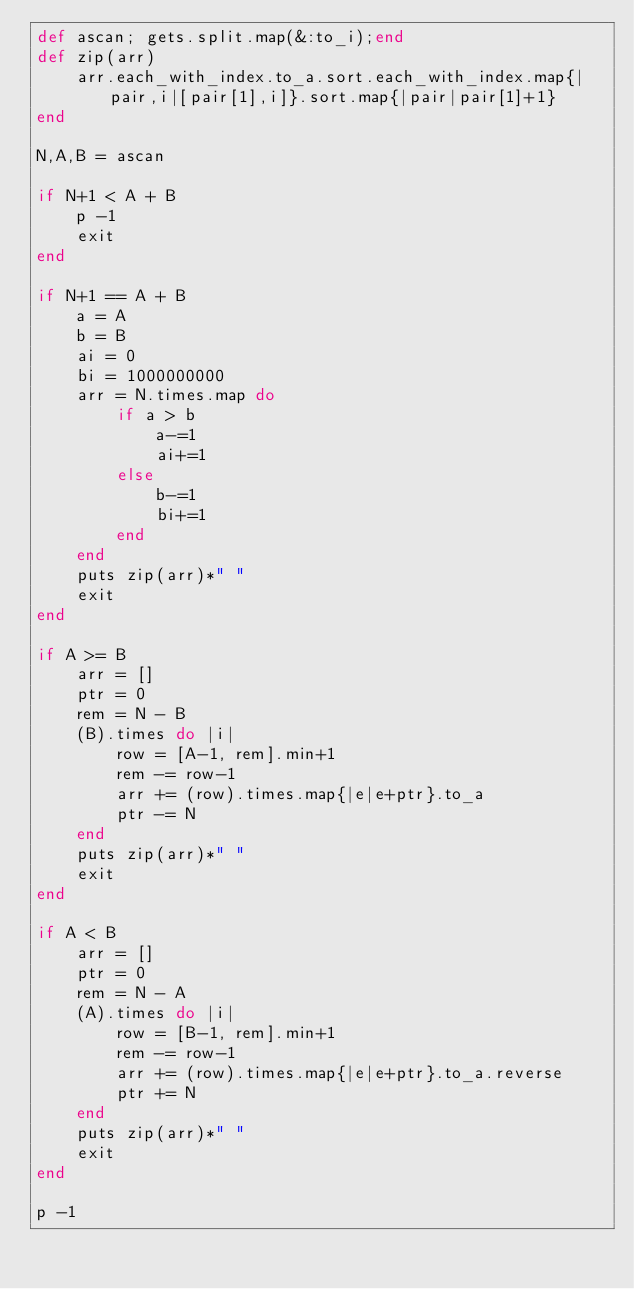Convert code to text. <code><loc_0><loc_0><loc_500><loc_500><_Ruby_>def ascan; gets.split.map(&:to_i);end
def zip(arr)
    arr.each_with_index.to_a.sort.each_with_index.map{|pair,i|[pair[1],i]}.sort.map{|pair|pair[1]+1}
end

N,A,B = ascan

if N+1 < A + B
    p -1
    exit
end

if N+1 == A + B
    a = A
    b = B
    ai = 0
    bi = 1000000000
    arr = N.times.map do
        if a > b
            a-=1
            ai+=1
        else
            b-=1
            bi+=1
        end
    end
    puts zip(arr)*" "
    exit
end

if A >= B
    arr = []
    ptr = 0
    rem = N - B
    (B).times do |i|
        row = [A-1, rem].min+1
        rem -= row-1
        arr += (row).times.map{|e|e+ptr}.to_a
        ptr -= N
    end
    puts zip(arr)*" "
    exit
end

if A < B
    arr = []
    ptr = 0
    rem = N - A
    (A).times do |i|
        row = [B-1, rem].min+1
        rem -= row-1
        arr += (row).times.map{|e|e+ptr}.to_a.reverse
        ptr += N
    end
    puts zip(arr)*" "
    exit
end

p -1</code> 